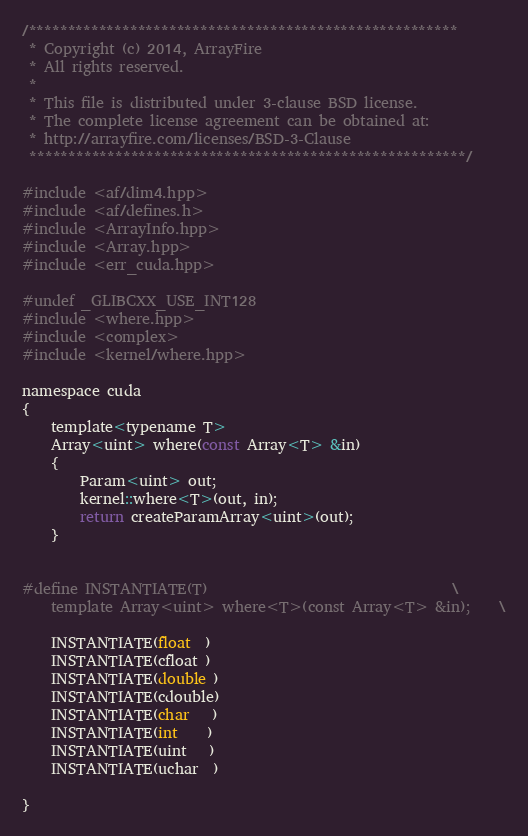Convert code to text. <code><loc_0><loc_0><loc_500><loc_500><_Cuda_>/*******************************************************
 * Copyright (c) 2014, ArrayFire
 * All rights reserved.
 *
 * This file is distributed under 3-clause BSD license.
 * The complete license agreement can be obtained at:
 * http://arrayfire.com/licenses/BSD-3-Clause
 ********************************************************/

#include <af/dim4.hpp>
#include <af/defines.h>
#include <ArrayInfo.hpp>
#include <Array.hpp>
#include <err_cuda.hpp>

#undef _GLIBCXX_USE_INT128
#include <where.hpp>
#include <complex>
#include <kernel/where.hpp>

namespace cuda
{
    template<typename T>
    Array<uint> where(const Array<T> &in)
    {
        Param<uint> out;
        kernel::where<T>(out, in);
        return createParamArray<uint>(out);
    }


#define INSTANTIATE(T)                                  \
    template Array<uint> where<T>(const Array<T> &in);    \

    INSTANTIATE(float  )
    INSTANTIATE(cfloat )
    INSTANTIATE(double )
    INSTANTIATE(cdouble)
    INSTANTIATE(char   )
    INSTANTIATE(int    )
    INSTANTIATE(uint   )
    INSTANTIATE(uchar  )

}
</code> 